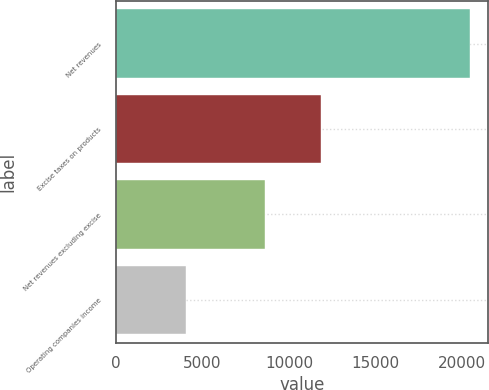<chart> <loc_0><loc_0><loc_500><loc_500><bar_chart><fcel>Net revenues<fcel>Excise taxes on products<fcel>Net revenues excluding excise<fcel>Operating companies income<nl><fcel>20469<fcel>11855<fcel>8614<fcel>4033<nl></chart> 